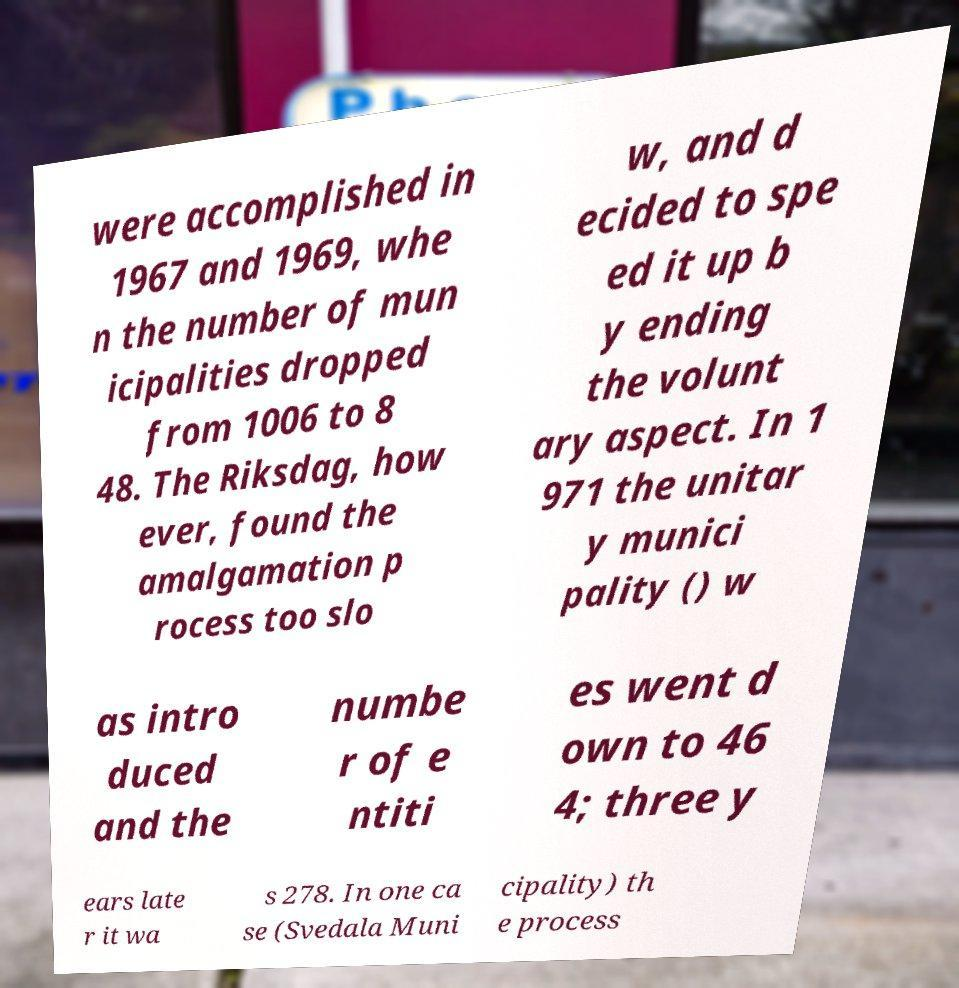Please read and relay the text visible in this image. What does it say? were accomplished in 1967 and 1969, whe n the number of mun icipalities dropped from 1006 to 8 48. The Riksdag, how ever, found the amalgamation p rocess too slo w, and d ecided to spe ed it up b y ending the volunt ary aspect. In 1 971 the unitar y munici pality () w as intro duced and the numbe r of e ntiti es went d own to 46 4; three y ears late r it wa s 278. In one ca se (Svedala Muni cipality) th e process 